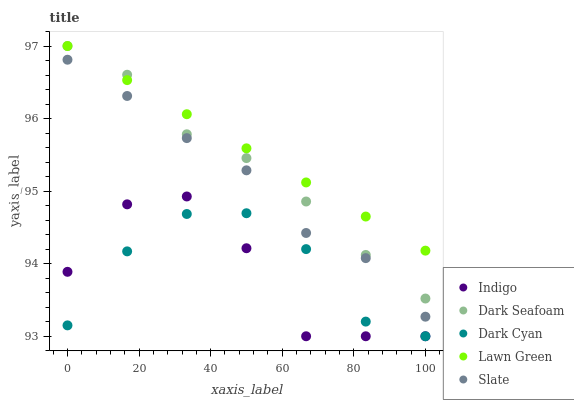Does Indigo have the minimum area under the curve?
Answer yes or no. Yes. Does Lawn Green have the maximum area under the curve?
Answer yes or no. Yes. Does Dark Seafoam have the minimum area under the curve?
Answer yes or no. No. Does Dark Seafoam have the maximum area under the curve?
Answer yes or no. No. Is Lawn Green the smoothest?
Answer yes or no. Yes. Is Indigo the roughest?
Answer yes or no. Yes. Is Dark Seafoam the smoothest?
Answer yes or no. No. Is Dark Seafoam the roughest?
Answer yes or no. No. Does Dark Cyan have the lowest value?
Answer yes or no. Yes. Does Dark Seafoam have the lowest value?
Answer yes or no. No. Does Dark Seafoam have the highest value?
Answer yes or no. Yes. Does Indigo have the highest value?
Answer yes or no. No. Is Indigo less than Slate?
Answer yes or no. Yes. Is Lawn Green greater than Slate?
Answer yes or no. Yes. Does Dark Seafoam intersect Lawn Green?
Answer yes or no. Yes. Is Dark Seafoam less than Lawn Green?
Answer yes or no. No. Is Dark Seafoam greater than Lawn Green?
Answer yes or no. No. Does Indigo intersect Slate?
Answer yes or no. No. 